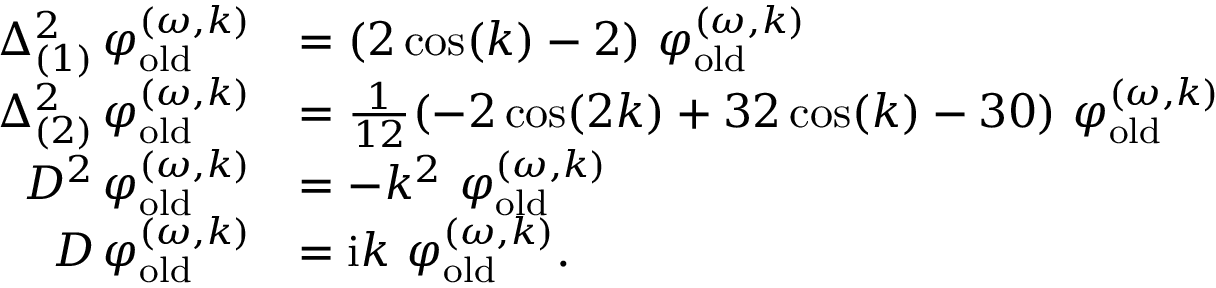<formula> <loc_0><loc_0><loc_500><loc_500>\begin{array} { r l } { \Delta _ { ( 1 ) } ^ { 2 } \, \varphi _ { o l d } ^ { ( \omega , k ) } } & { = ( 2 \cos ( k ) - 2 ) \ \varphi _ { o l d } ^ { ( \omega , k ) } } \\ { \Delta _ { ( 2 ) } ^ { 2 } \, \varphi _ { o l d } ^ { ( \omega , k ) } } & { = \frac { 1 } { 1 2 } ( - 2 \cos ( 2 k ) + 3 2 \cos ( k ) - 3 0 ) \ \varphi _ { o l d } ^ { ( \omega , k ) } } \\ { D ^ { 2 } \, \varphi _ { o l d } ^ { ( \omega , k ) } } & { = - k ^ { 2 } \ \varphi _ { o l d } ^ { ( \omega , k ) } } \\ { D \, \varphi _ { o l d } ^ { ( \omega , k ) } } & { = i k \ \varphi _ { o l d } ^ { ( \omega , k ) } . } \end{array}</formula> 